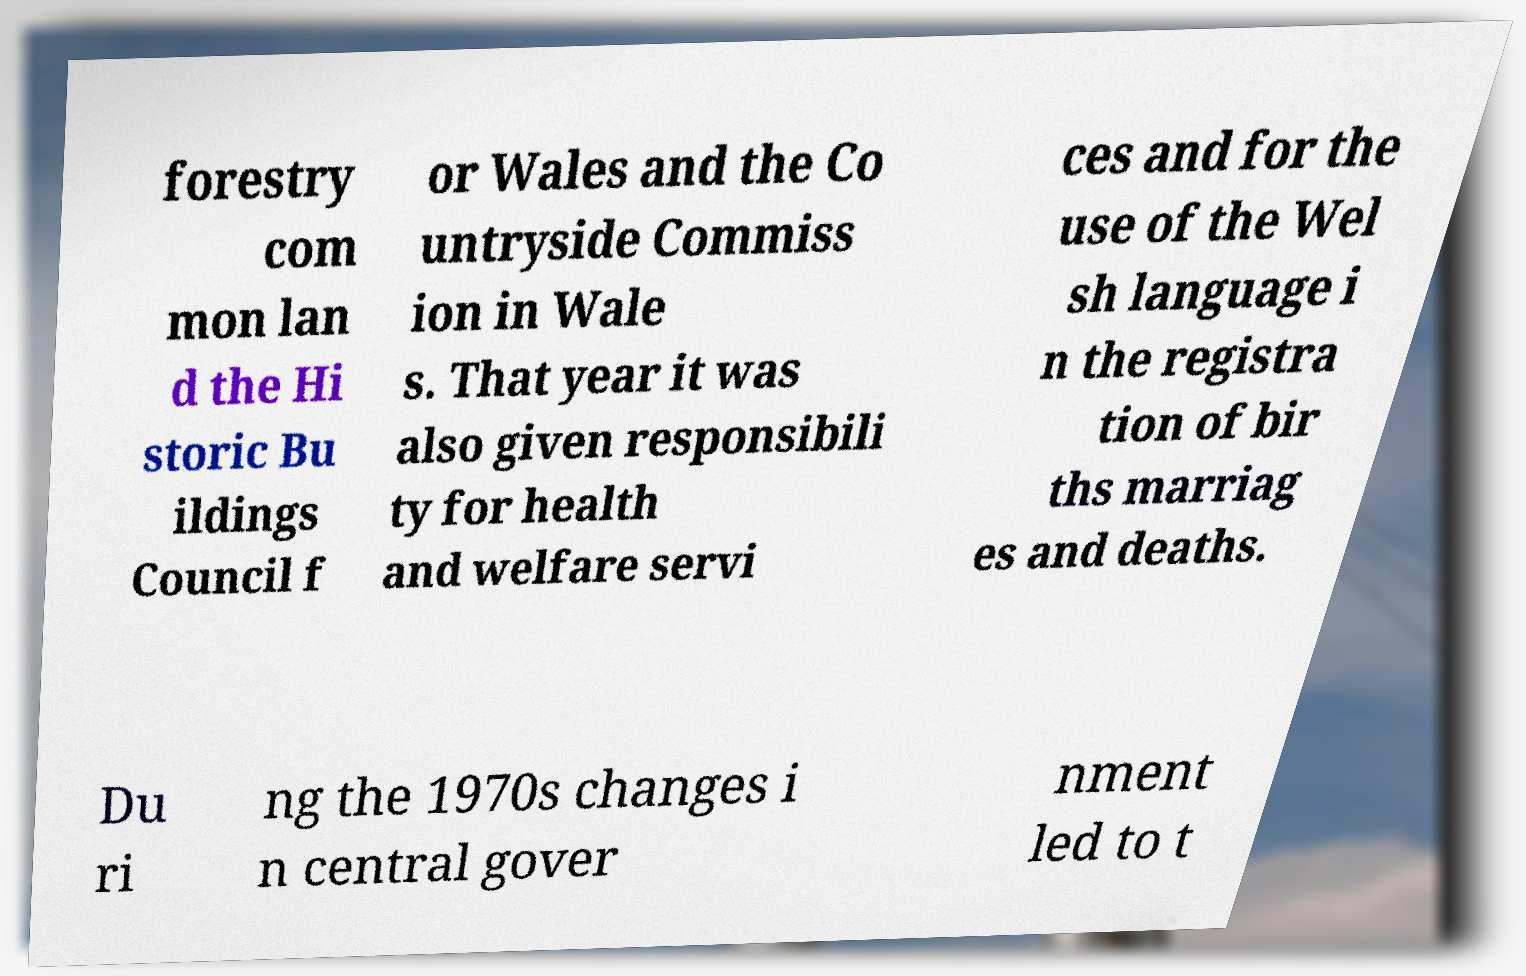Could you assist in decoding the text presented in this image and type it out clearly? forestry com mon lan d the Hi storic Bu ildings Council f or Wales and the Co untryside Commiss ion in Wale s. That year it was also given responsibili ty for health and welfare servi ces and for the use of the Wel sh language i n the registra tion of bir ths marriag es and deaths. Du ri ng the 1970s changes i n central gover nment led to t 